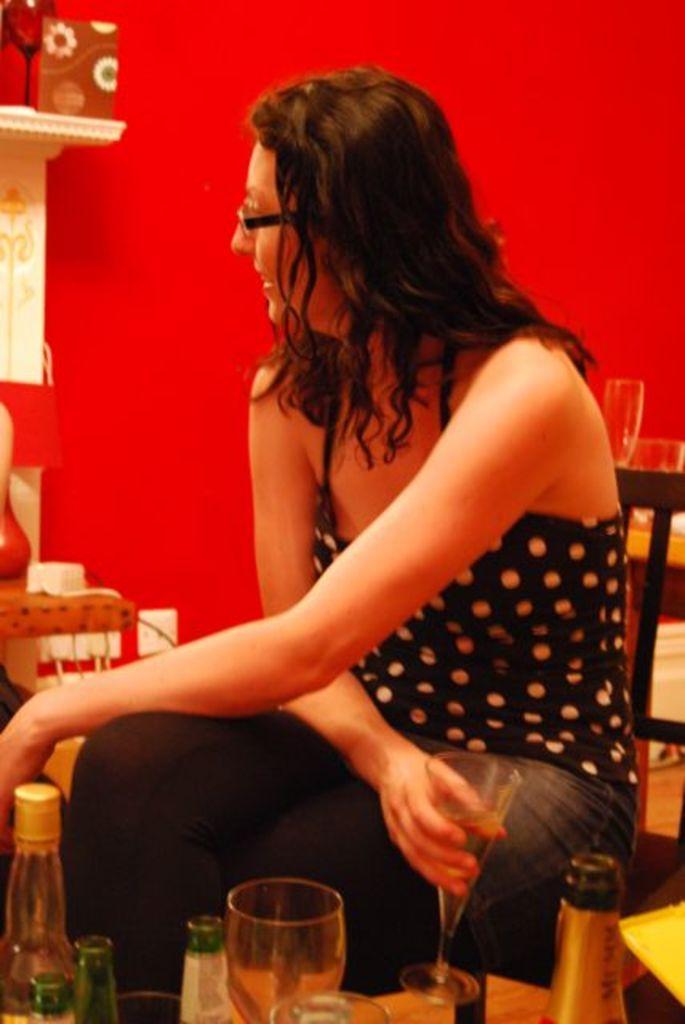Describe this image in one or two sentences. A girl is sitting in the chair holding a wine glass in her hand. She wears a Spectacles and a black color dress there are wine and beer bottles at here behind her there is a red color wall. 